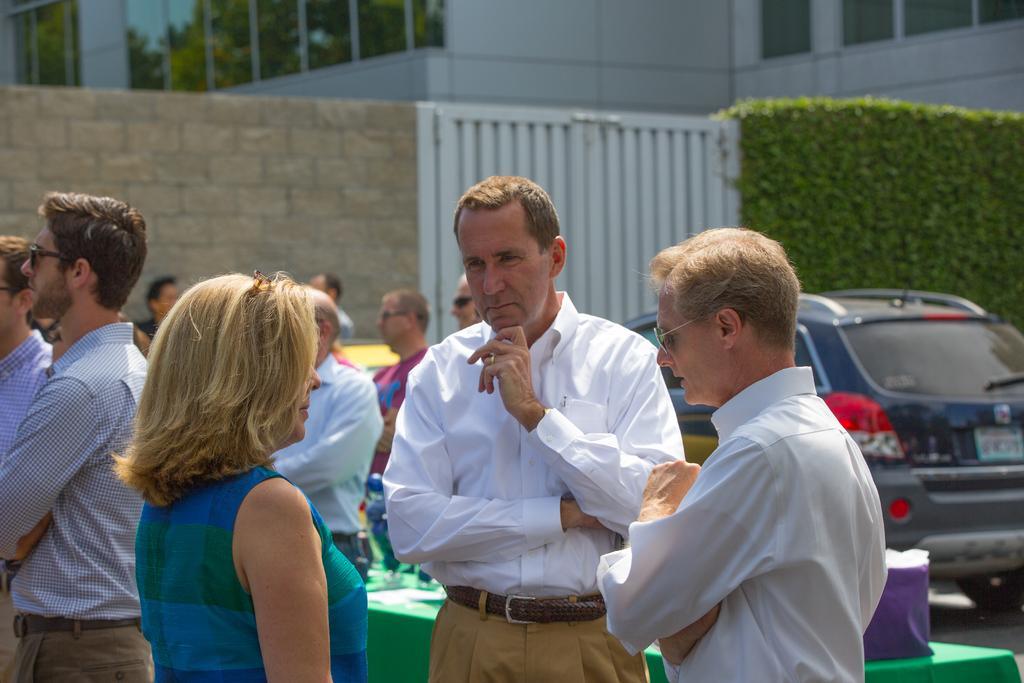How would you summarize this image in a sentence or two? In this picture we can see a group of people, vehicle, cloth and some objects and in the background we can see the wall, wooden gate, plants and a building. 